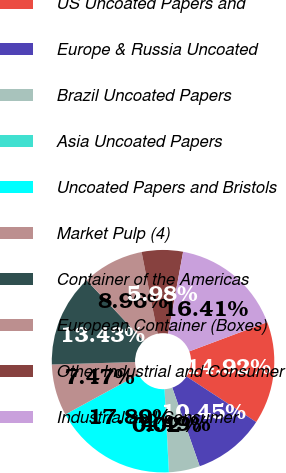<chart> <loc_0><loc_0><loc_500><loc_500><pie_chart><fcel>US Uncoated Papers and<fcel>Europe & Russia Uncoated<fcel>Brazil Uncoated Papers<fcel>Asia Uncoated Papers<fcel>Uncoated Papers and Bristols<fcel>Market Pulp (4)<fcel>Container of the Americas<fcel>European Container (Boxes)<fcel>Other Industrial and Consumer<fcel>Industrial and Consumer<nl><fcel>14.92%<fcel>10.45%<fcel>4.49%<fcel>0.02%<fcel>17.9%<fcel>7.47%<fcel>13.43%<fcel>8.96%<fcel>5.98%<fcel>16.41%<nl></chart> 